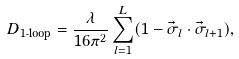Convert formula to latex. <formula><loc_0><loc_0><loc_500><loc_500>D _ { \text {1-loop} } = \frac { \lambda } { 1 6 \pi ^ { 2 } } \sum _ { l = 1 } ^ { L } ( 1 - \vec { \sigma } _ { l } \cdot \vec { \sigma } _ { l + 1 } ) ,</formula> 